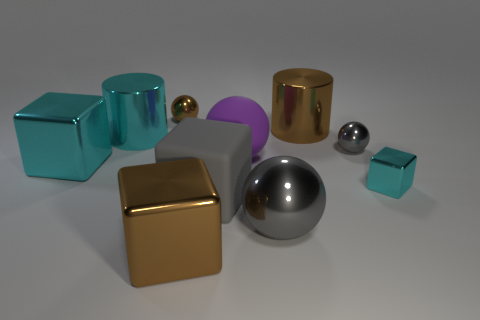There is a large rubber ball; does it have the same color as the shiny cylinder to the right of the large gray metallic thing?
Provide a succinct answer. No. Is there anything else that is the same color as the large matte block?
Your answer should be very brief. Yes. Are there fewer large cyan cylinders that are in front of the big cyan metallic cube than big cyan blocks?
Your response must be concise. Yes. How many other gray cubes are the same size as the gray block?
Your answer should be very brief. 0. There is a tiny thing that is the same color as the matte cube; what shape is it?
Offer a very short reply. Sphere. There is a big rubber thing in front of the cyan cube that is on the right side of the shiny sphere in front of the large cyan cube; what is its shape?
Keep it short and to the point. Cube. There is a large sphere that is in front of the large purple sphere; what color is it?
Offer a very short reply. Gray. What number of things are either cyan things left of the small metal block or metallic blocks that are behind the small shiny cube?
Give a very brief answer. 2. How many other metal things are the same shape as the purple object?
Your answer should be compact. 3. What is the color of the matte ball that is the same size as the gray matte object?
Keep it short and to the point. Purple. 